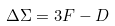Convert formula to latex. <formula><loc_0><loc_0><loc_500><loc_500>\Delta \Sigma = 3 F - D</formula> 